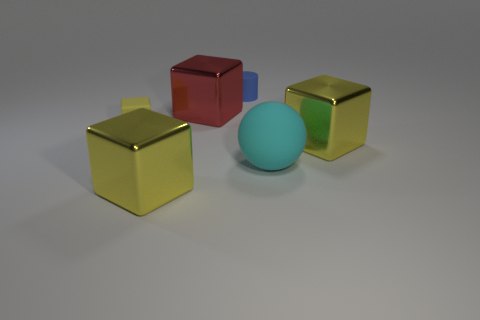Subtract all gray balls. How many yellow cubes are left? 3 Subtract all gray blocks. Subtract all yellow spheres. How many blocks are left? 4 Add 2 cylinders. How many objects exist? 8 Subtract all blocks. How many objects are left? 2 Add 2 shiny balls. How many shiny balls exist? 2 Subtract 0 purple spheres. How many objects are left? 6 Subtract all tiny matte blocks. Subtract all tiny matte balls. How many objects are left? 5 Add 2 yellow things. How many yellow things are left? 5 